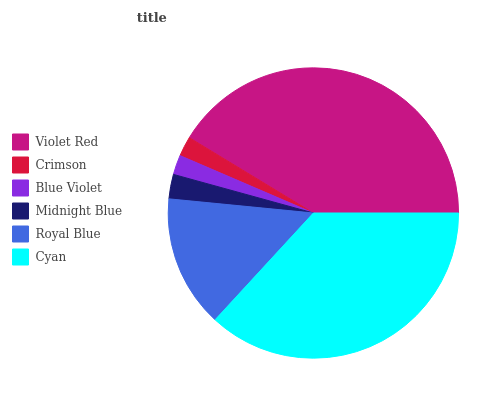Is Blue Violet the minimum?
Answer yes or no. Yes. Is Violet Red the maximum?
Answer yes or no. Yes. Is Crimson the minimum?
Answer yes or no. No. Is Crimson the maximum?
Answer yes or no. No. Is Violet Red greater than Crimson?
Answer yes or no. Yes. Is Crimson less than Violet Red?
Answer yes or no. Yes. Is Crimson greater than Violet Red?
Answer yes or no. No. Is Violet Red less than Crimson?
Answer yes or no. No. Is Royal Blue the high median?
Answer yes or no. Yes. Is Midnight Blue the low median?
Answer yes or no. Yes. Is Cyan the high median?
Answer yes or no. No. Is Crimson the low median?
Answer yes or no. No. 